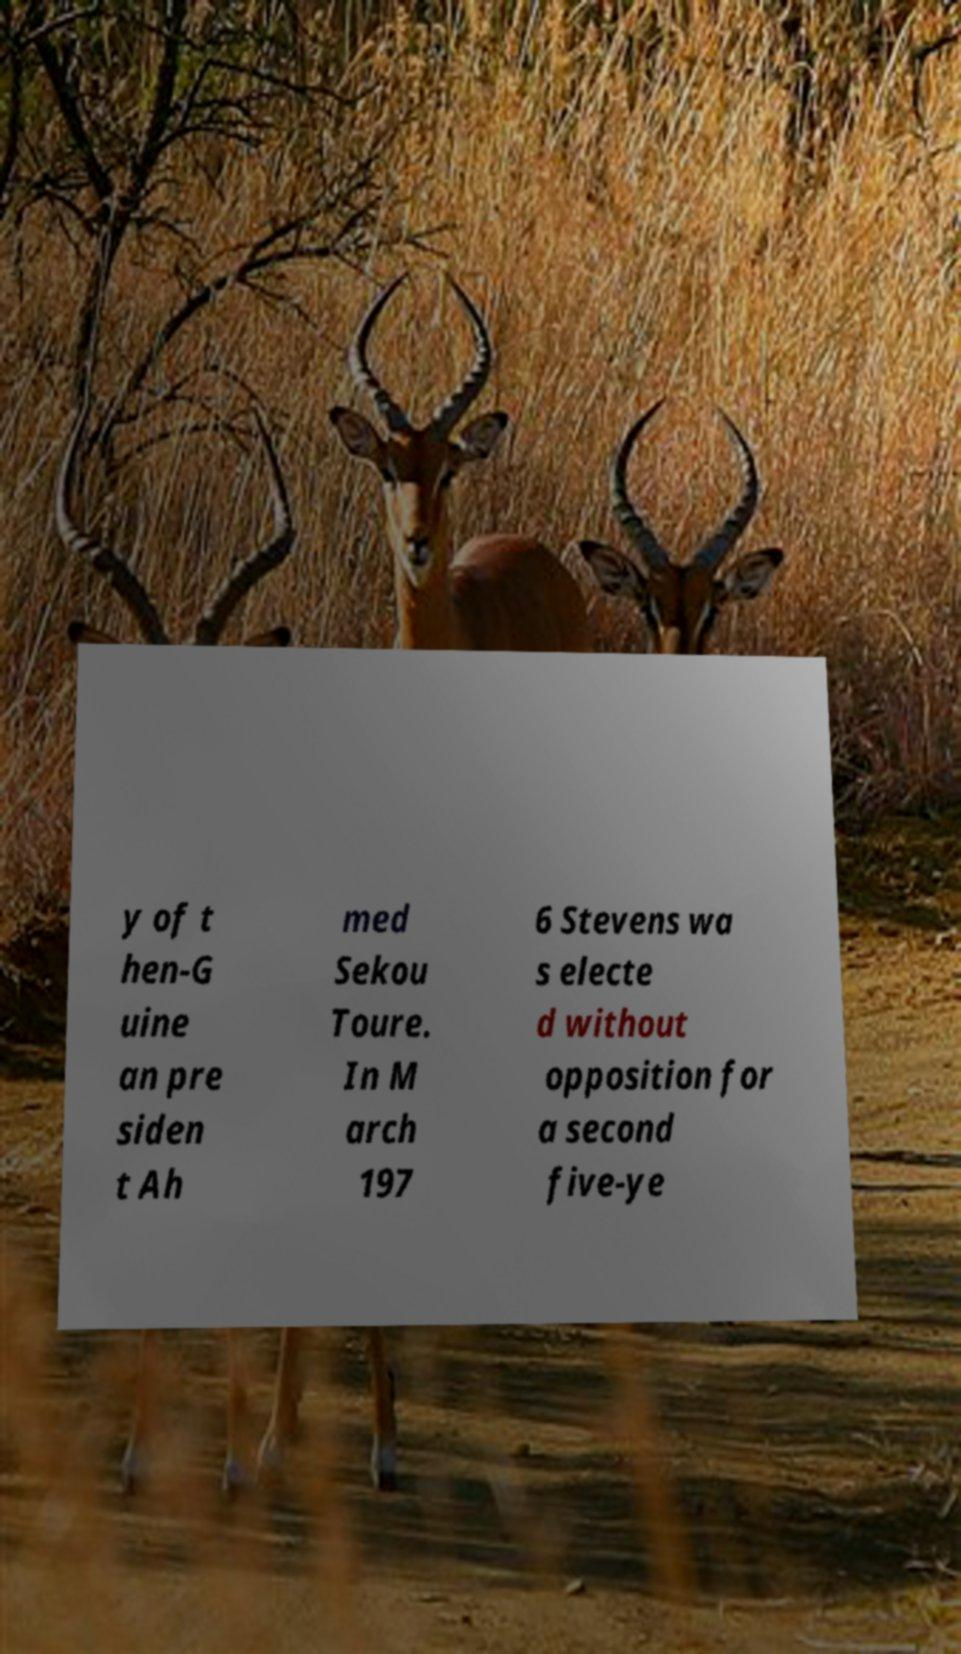Please identify and transcribe the text found in this image. y of t hen-G uine an pre siden t Ah med Sekou Toure. In M arch 197 6 Stevens wa s electe d without opposition for a second five-ye 